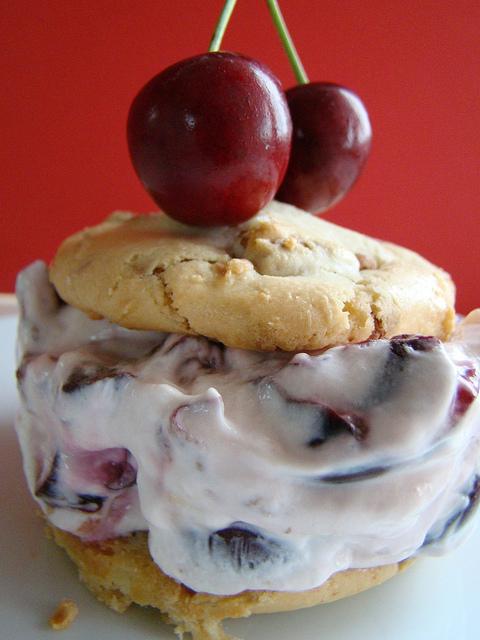How many cherries are on top?
Answer briefly. 2. What fruit is on top?
Keep it brief. Cherry. What is in the middle of these cookies?
Concise answer only. Ice cream. 